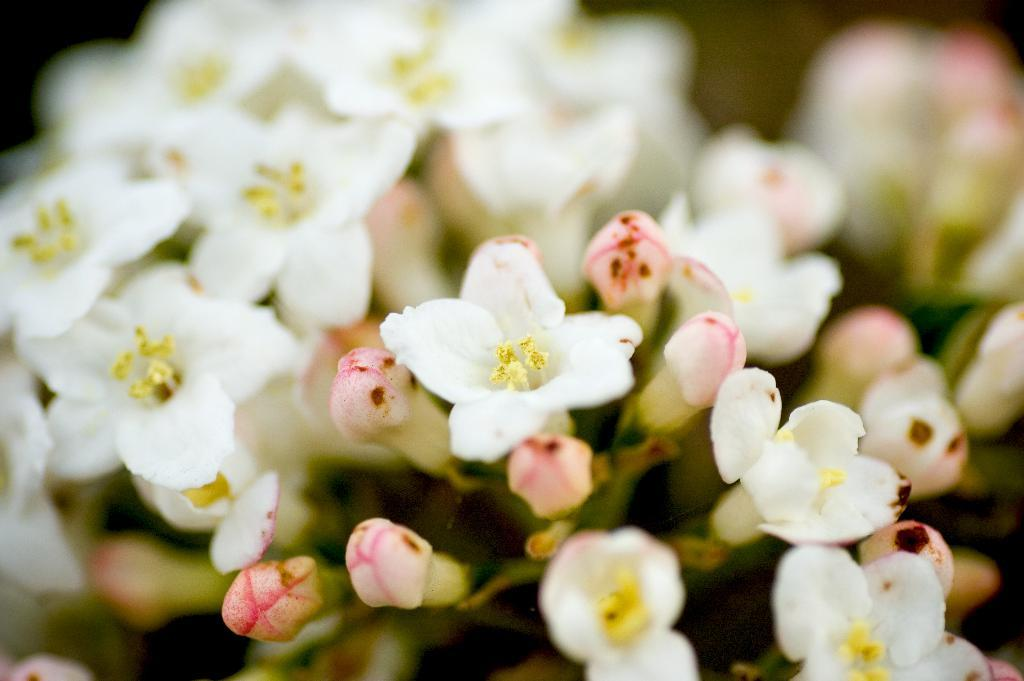What type of flowers are present in the image? There are white flowers in the image. Can you describe the background of the image? The background of the image is blurred. Where can you buy these flowers in the image? The image does not provide information about where to buy the flowers. What fact can be learned about the flowers in the image? The facts provided do not offer any additional information about the flowers beyond their color. What songs are playing in the background of the image? There is no mention of any songs playing in the background of the image. 